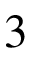Convert formula to latex. <formula><loc_0><loc_0><loc_500><loc_500>3</formula> 